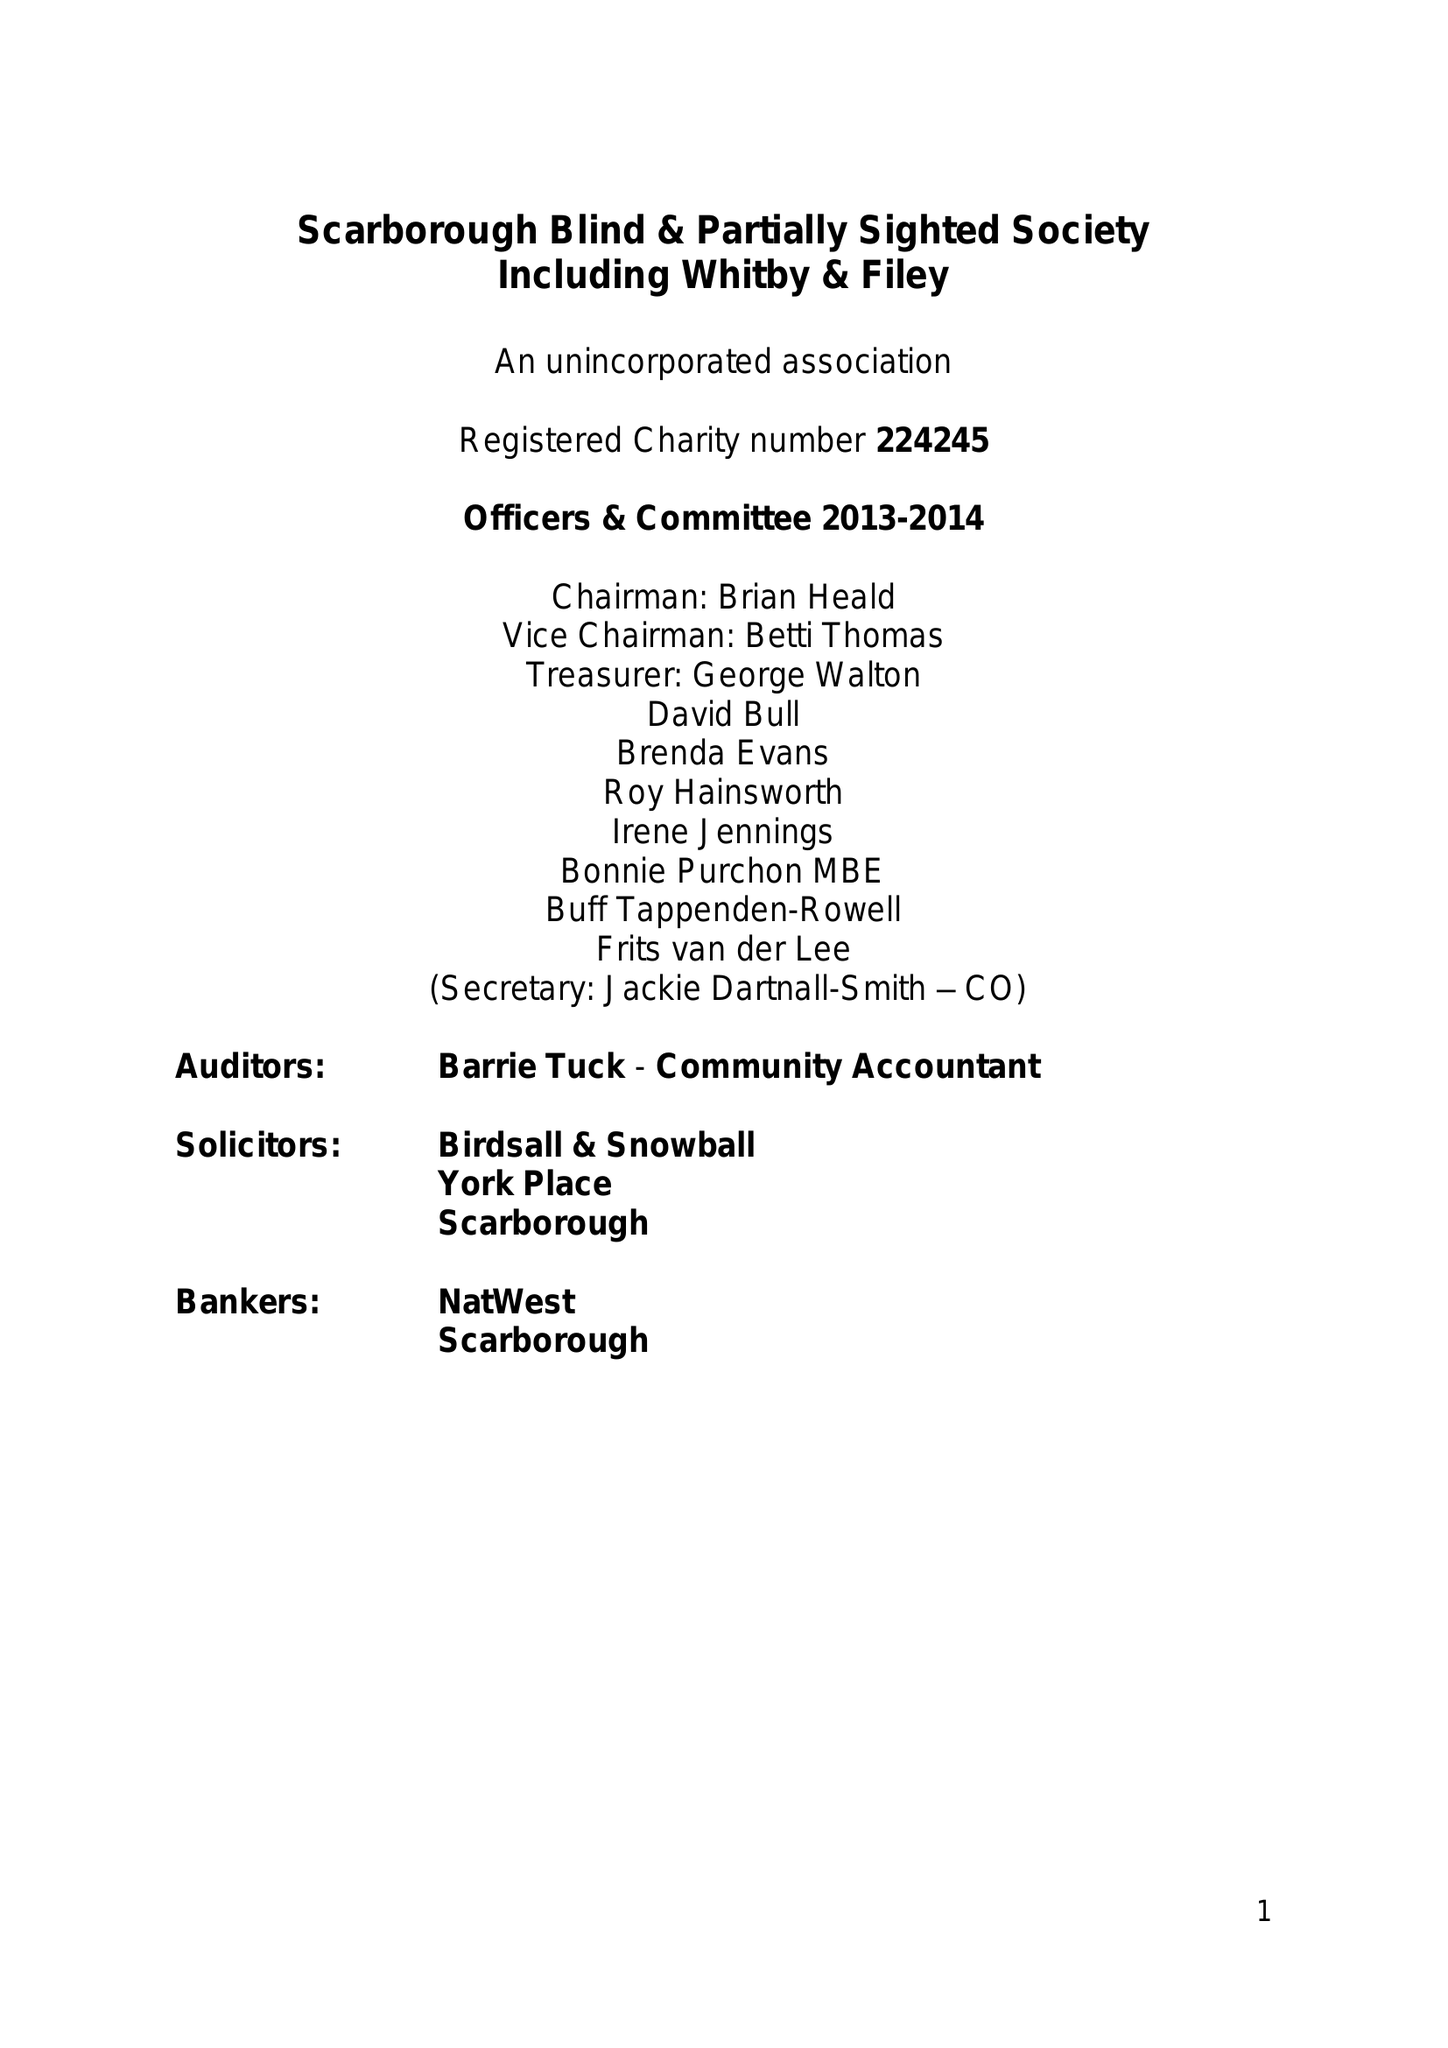What is the value for the report_date?
Answer the question using a single word or phrase. 2014-03-31 